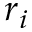Convert formula to latex. <formula><loc_0><loc_0><loc_500><loc_500>r _ { i }</formula> 